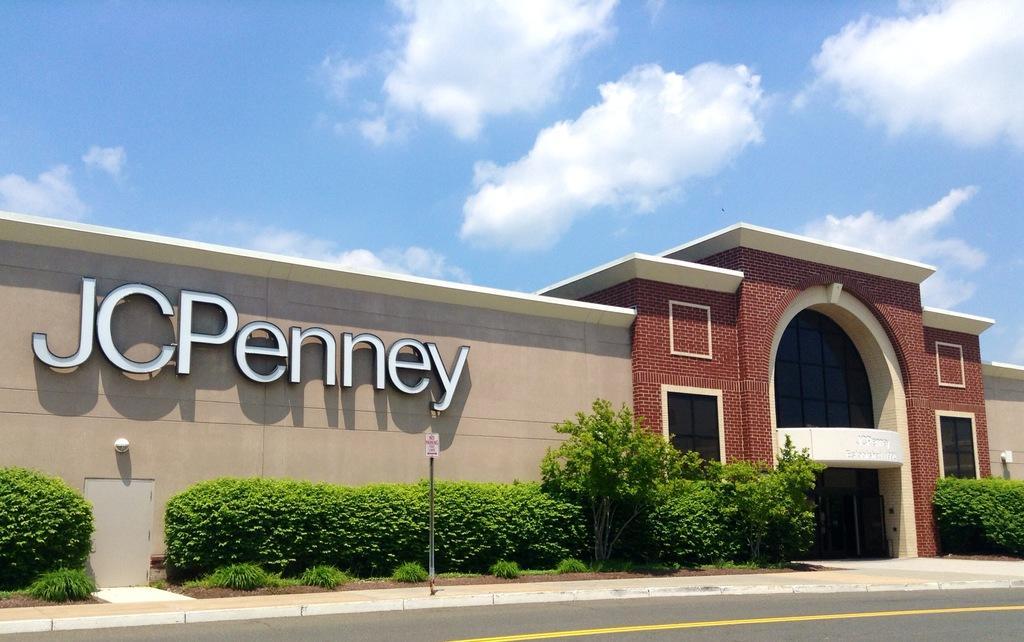Describe this image in one or two sentences. This is the front of a building. And there is something written on the building. Also it is having a brick wall. In the front of the building there are bushes and plants. Also there is a pole with a name board. Also there is a road. In the background there is sky with clouds. 